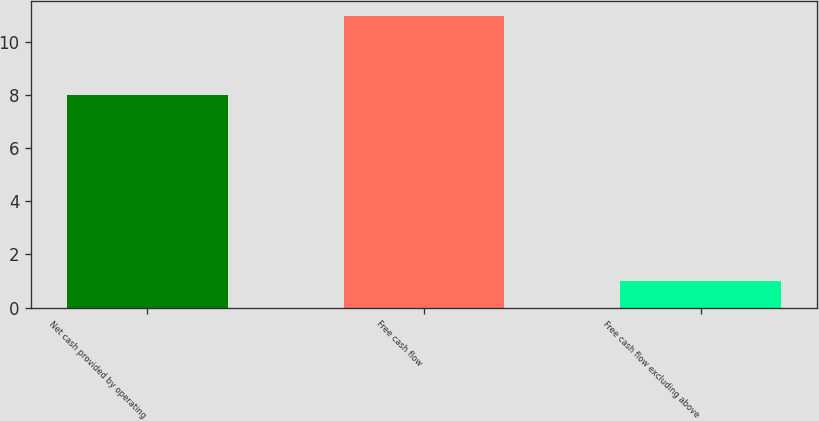Convert chart. <chart><loc_0><loc_0><loc_500><loc_500><bar_chart><fcel>Net cash provided by operating<fcel>Free cash flow<fcel>Free cash flow excluding above<nl><fcel>8<fcel>11<fcel>1<nl></chart> 